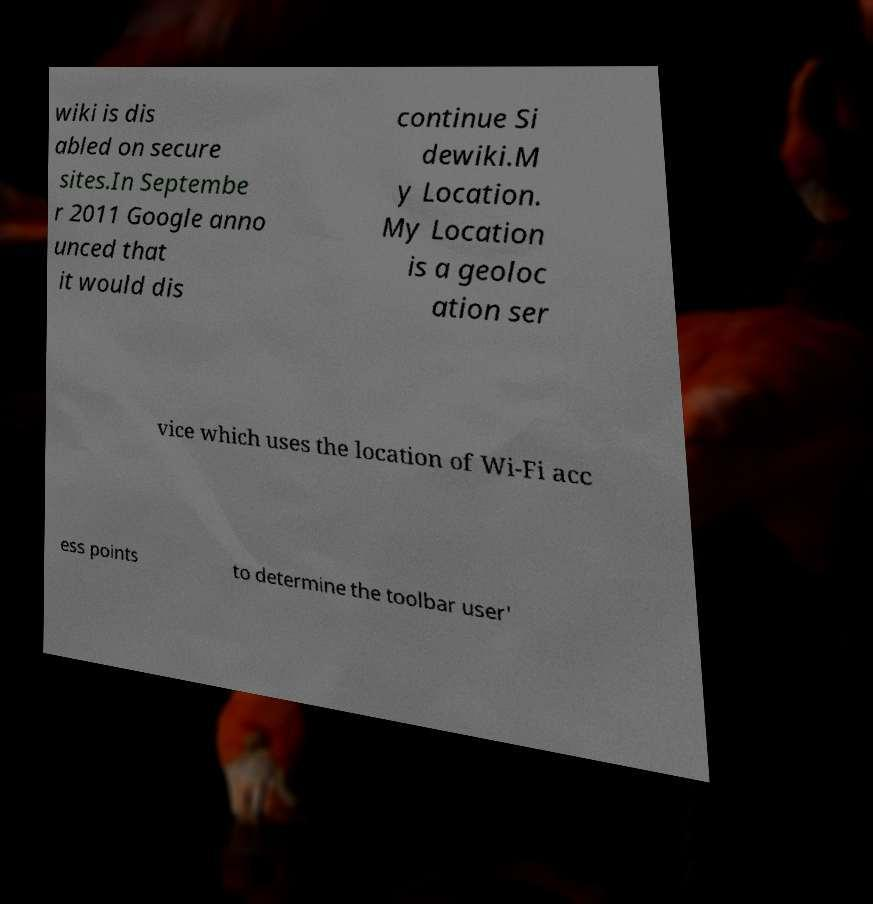Can you accurately transcribe the text from the provided image for me? wiki is dis abled on secure sites.In Septembe r 2011 Google anno unced that it would dis continue Si dewiki.M y Location. My Location is a geoloc ation ser vice which uses the location of Wi-Fi acc ess points to determine the toolbar user' 